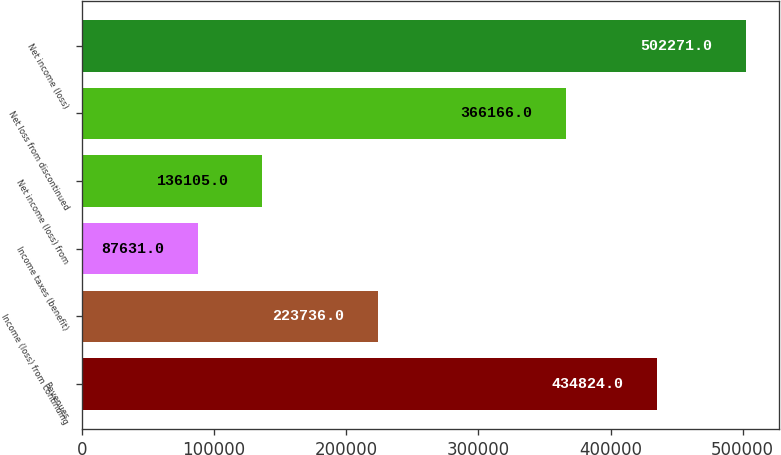Convert chart to OTSL. <chart><loc_0><loc_0><loc_500><loc_500><bar_chart><fcel>Revenues<fcel>Income (loss) from continuing<fcel>Income taxes (benefit)<fcel>Net income (loss) from<fcel>Net loss from discontinued<fcel>Net income (loss)<nl><fcel>434824<fcel>223736<fcel>87631<fcel>136105<fcel>366166<fcel>502271<nl></chart> 